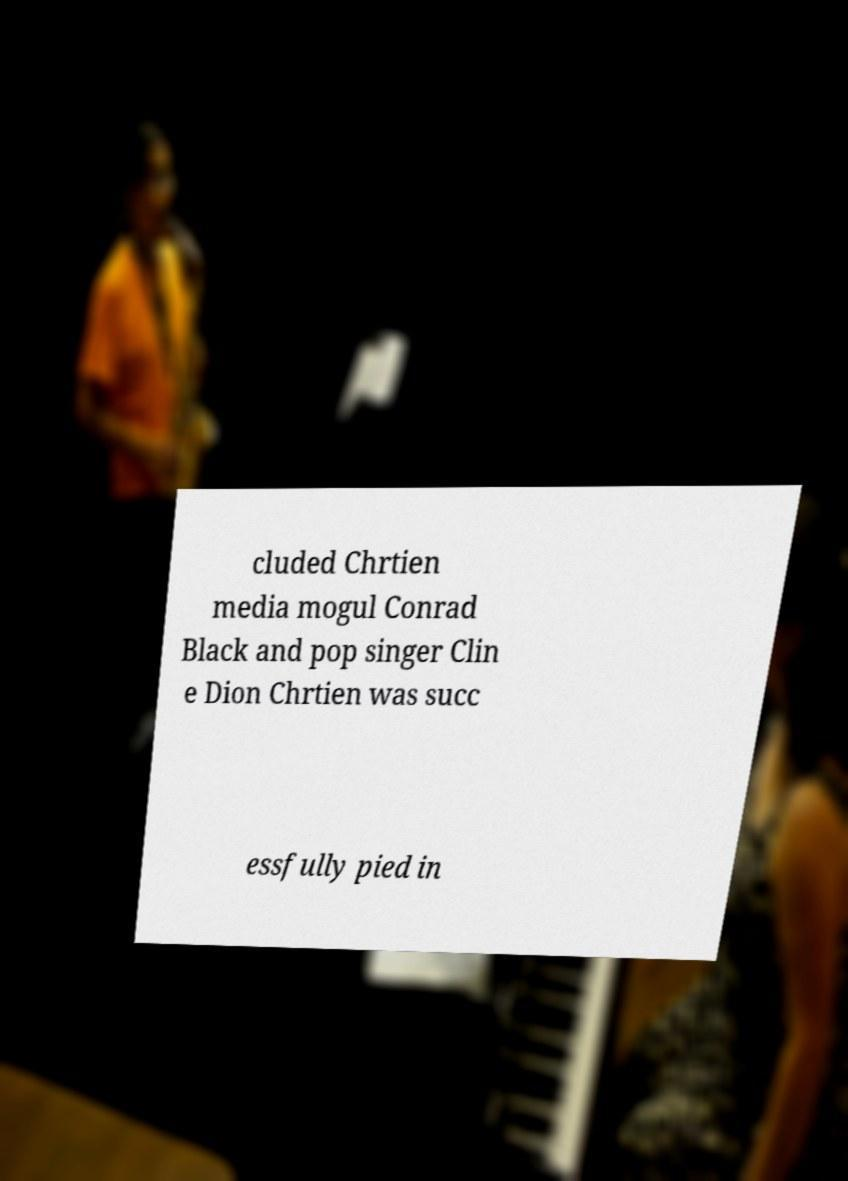For documentation purposes, I need the text within this image transcribed. Could you provide that? cluded Chrtien media mogul Conrad Black and pop singer Clin e Dion Chrtien was succ essfully pied in 